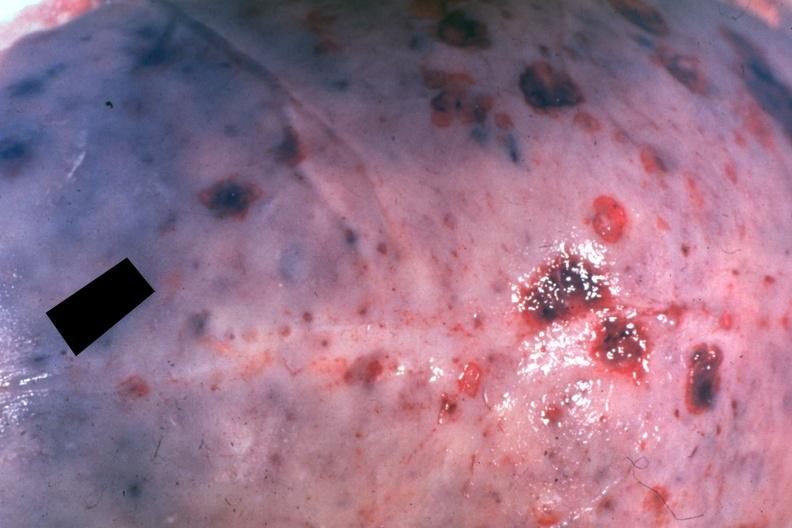does this image show dr garcia tumors b6?
Answer the question using a single word or phrase. Yes 